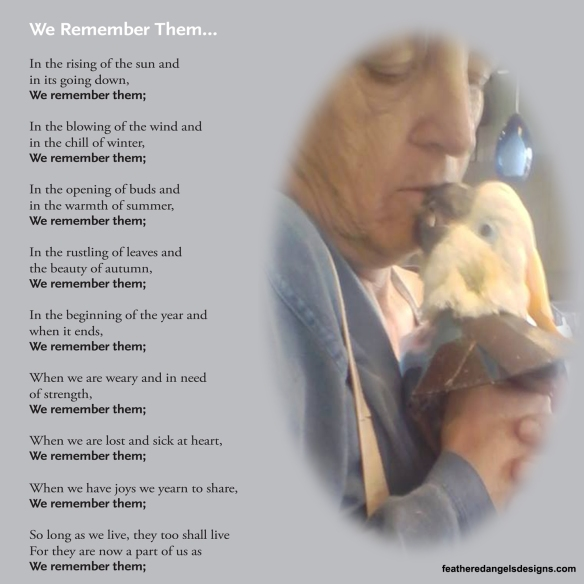What emotions do you think the person is experiencing while interacting with the bird? The person in the image appears to be experiencing deep emotions of love, tenderness, and perhaps sadness. The act of kissing the bird signifies a close and cherished bond, suggesting that the person holds the bird dear. This intimate moment might be a way for the person to express gratitude, affection, or even a poignant goodbye, reflecting a deep connection that goes beyond words.  How might this image and poem inspire someone who has recently lost a beloved pet? This image and poem together can offer solace to someone who has recently lost a beloved pet by emphasizing the importance of treasuring memories. The poem's repetitive phrase, 'We remember them,' and the tender interaction in the image remind us that the bonds we share with our pets continue in our hearts and memories, providing comfort in times of grief. It reinforces the message that the love and joy pets bring to our lives are eternal, and their presence continues even after they are gone. 